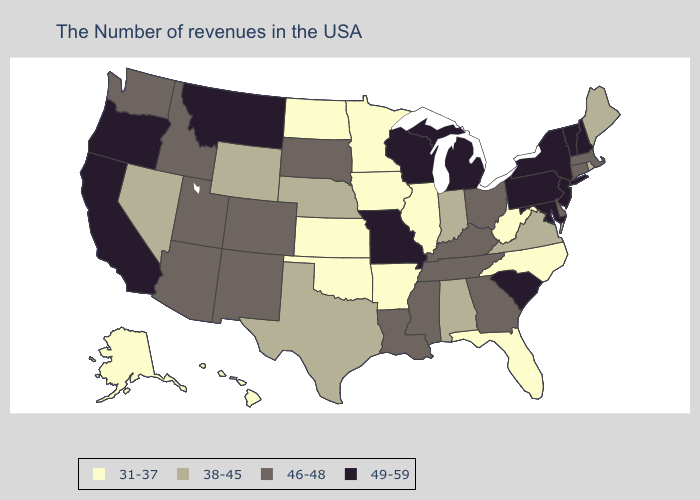Name the states that have a value in the range 38-45?
Be succinct. Maine, Rhode Island, Virginia, Indiana, Alabama, Nebraska, Texas, Wyoming, Nevada. What is the highest value in the West ?
Concise answer only. 49-59. Does Rhode Island have a lower value than Minnesota?
Be succinct. No. What is the highest value in states that border Maryland?
Write a very short answer. 49-59. Which states have the highest value in the USA?
Be succinct. New Hampshire, Vermont, New York, New Jersey, Maryland, Pennsylvania, South Carolina, Michigan, Wisconsin, Missouri, Montana, California, Oregon. Does Arkansas have the lowest value in the USA?
Keep it brief. Yes. Name the states that have a value in the range 31-37?
Be succinct. North Carolina, West Virginia, Florida, Illinois, Arkansas, Minnesota, Iowa, Kansas, Oklahoma, North Dakota, Alaska, Hawaii. What is the value of North Carolina?
Be succinct. 31-37. Which states have the lowest value in the MidWest?
Short answer required. Illinois, Minnesota, Iowa, Kansas, North Dakota. What is the highest value in the USA?
Be succinct. 49-59. Name the states that have a value in the range 31-37?
Be succinct. North Carolina, West Virginia, Florida, Illinois, Arkansas, Minnesota, Iowa, Kansas, Oklahoma, North Dakota, Alaska, Hawaii. What is the highest value in the USA?
Write a very short answer. 49-59. What is the lowest value in states that border Illinois?
Give a very brief answer. 31-37. What is the highest value in states that border Colorado?
Keep it brief. 46-48. What is the highest value in states that border Connecticut?
Give a very brief answer. 49-59. 